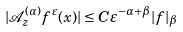<formula> <loc_0><loc_0><loc_500><loc_500>| \mathcal { A } _ { z } ^ { ( \alpha ) } f ^ { \varepsilon } ( x ) | \leq C \varepsilon ^ { - \alpha + \beta } | f | _ { \beta }</formula> 